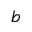<formula> <loc_0><loc_0><loc_500><loc_500>b</formula> 